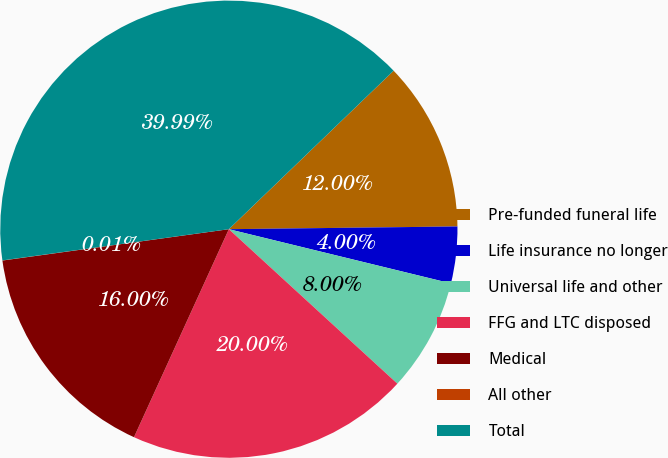Convert chart to OTSL. <chart><loc_0><loc_0><loc_500><loc_500><pie_chart><fcel>Pre-funded funeral life<fcel>Life insurance no longer<fcel>Universal life and other<fcel>FFG and LTC disposed<fcel>Medical<fcel>All other<fcel>Total<nl><fcel>12.0%<fcel>4.0%<fcel>8.0%<fcel>20.0%<fcel>16.0%<fcel>0.01%<fcel>39.99%<nl></chart> 